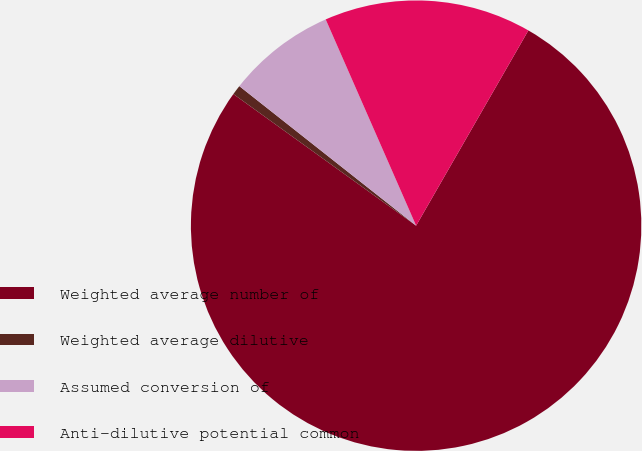Convert chart. <chart><loc_0><loc_0><loc_500><loc_500><pie_chart><fcel>Weighted average number of<fcel>Weighted average dilutive<fcel>Assumed conversion of<fcel>Anti-dilutive potential common<nl><fcel>76.63%<fcel>0.7%<fcel>7.79%<fcel>14.88%<nl></chart> 